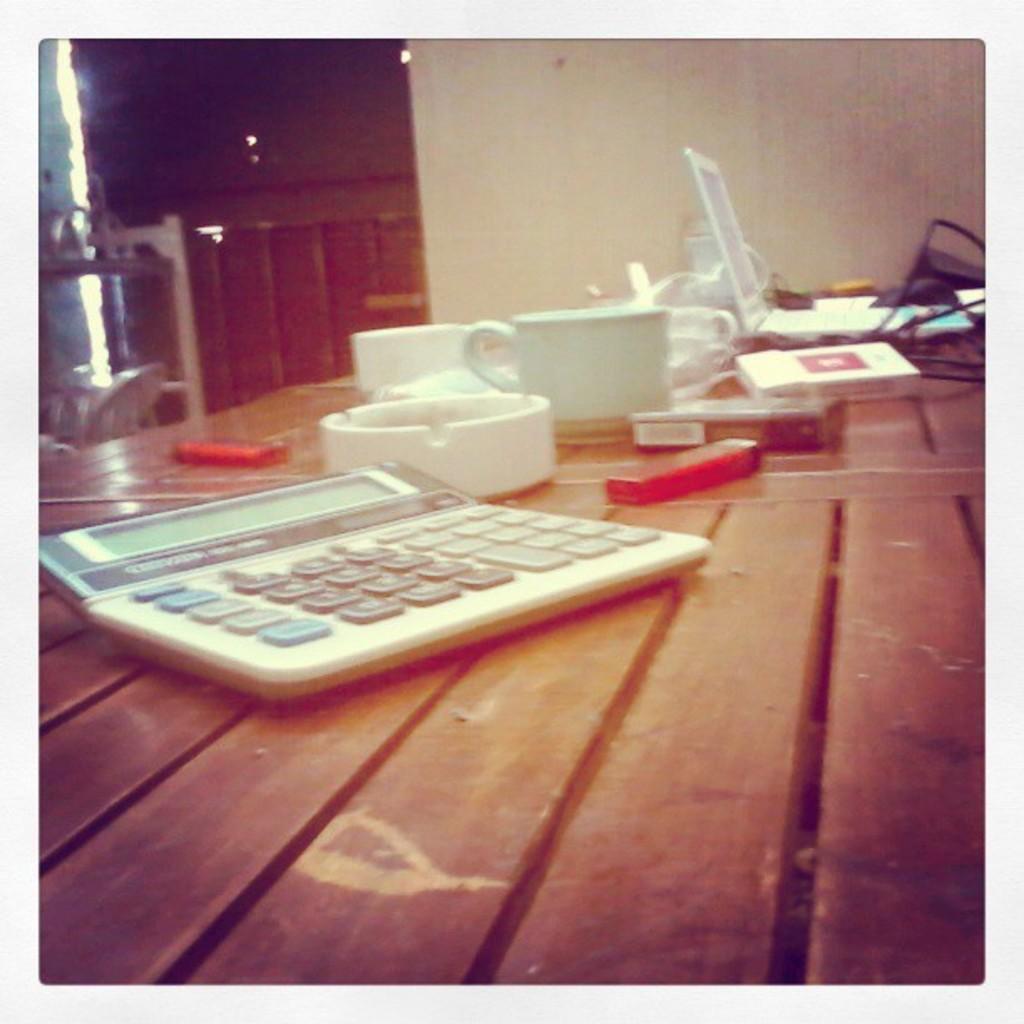Describe this image in one or two sentences. in the picture we can see a table on the table we can see a calculator along with the laptop and a cup. 